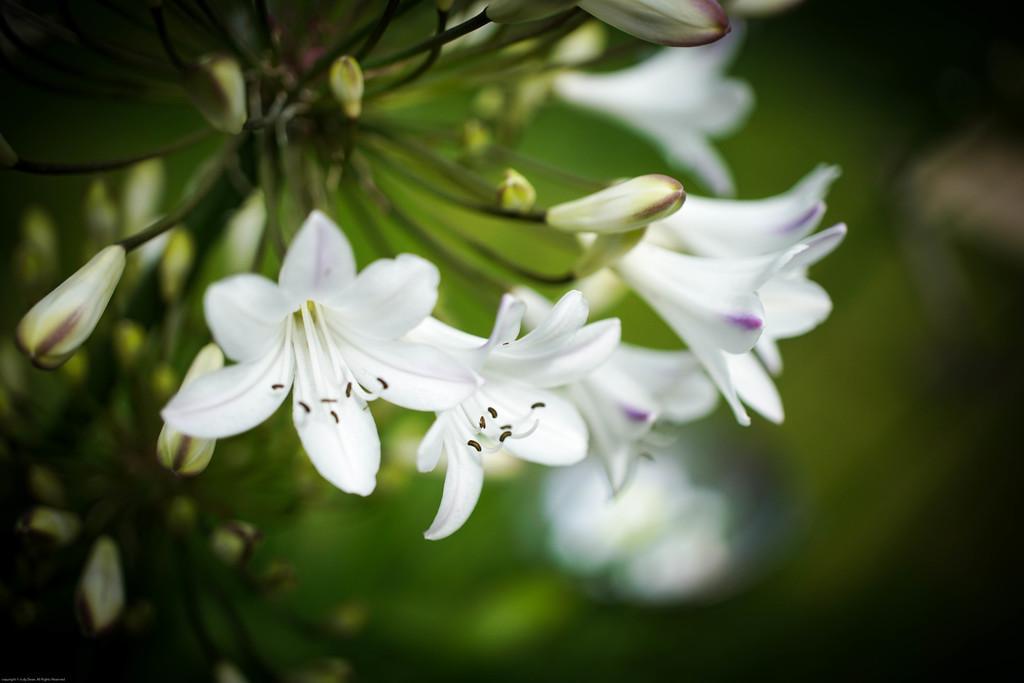How would you summarize this image in a sentence or two? In this image there are flowers which are in white color and we can see buds. 